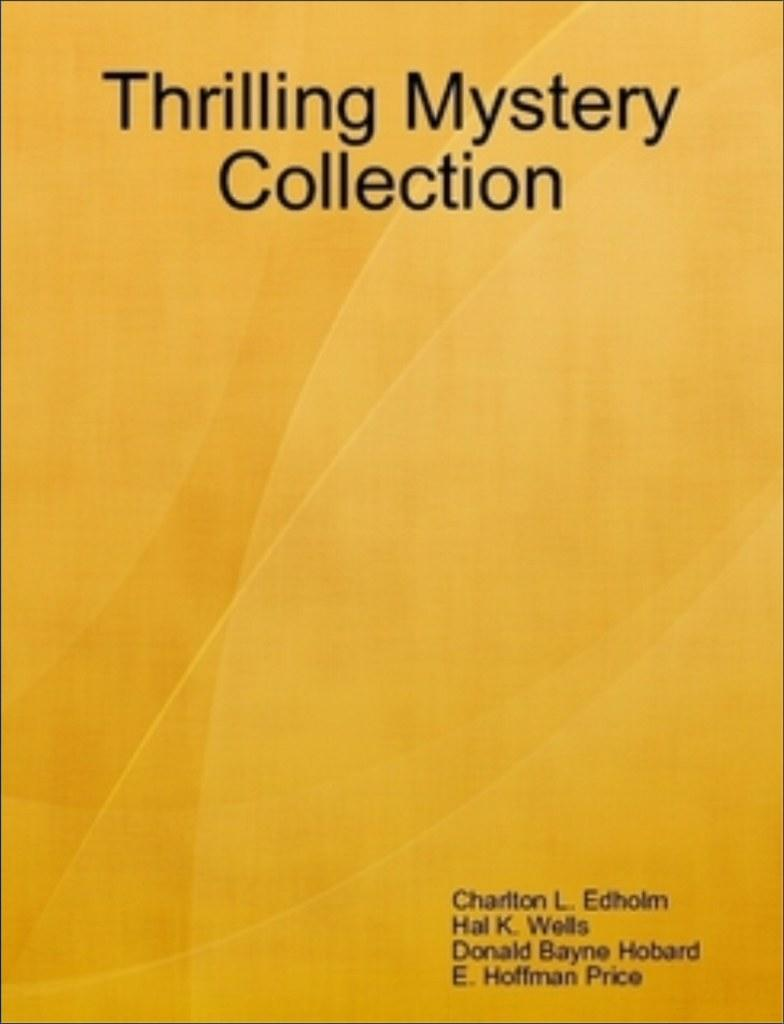<image>
Relay a brief, clear account of the picture shown. A booked titled Thrilling Mystery Collection by Charlton L Edholm has a vibrant yellow cover 